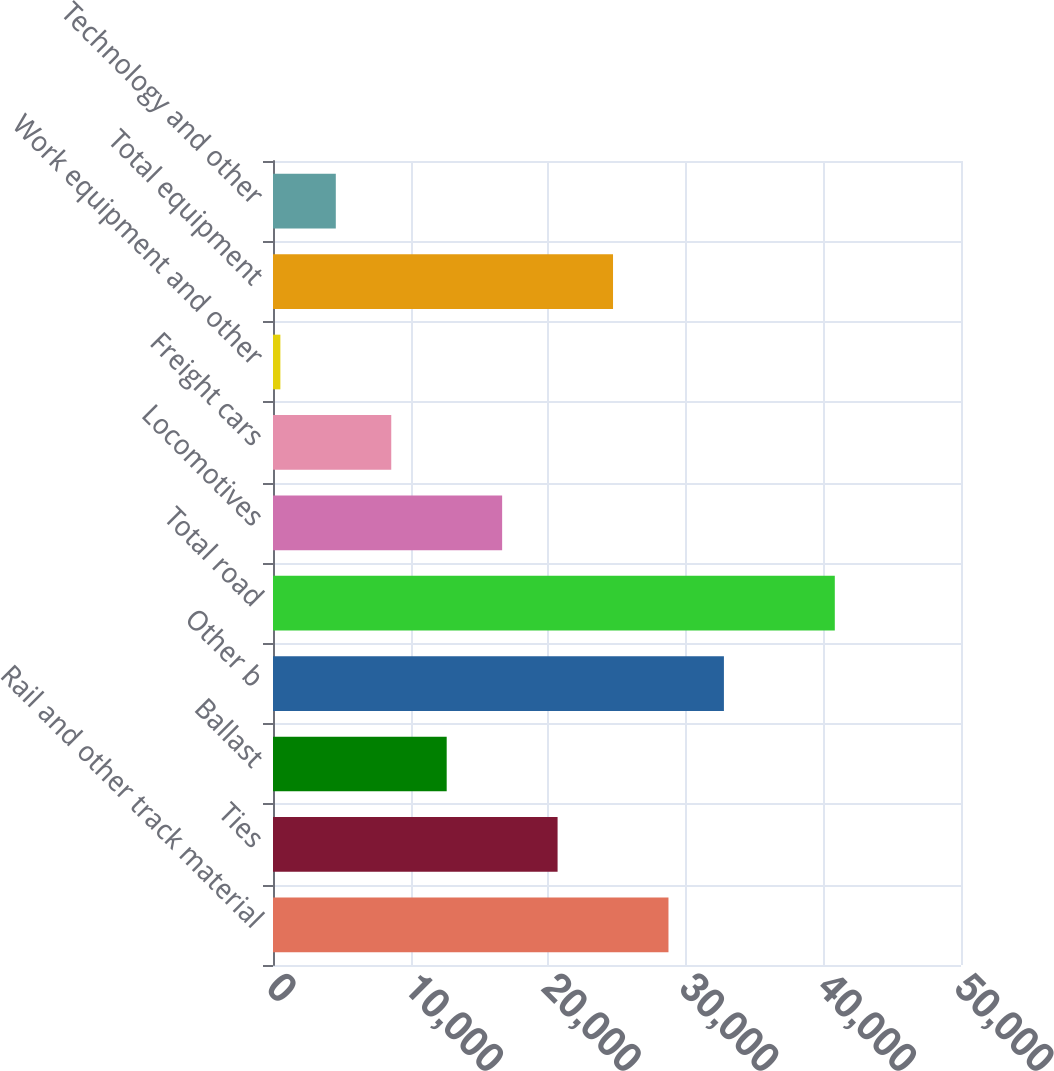<chart> <loc_0><loc_0><loc_500><loc_500><bar_chart><fcel>Rail and other track material<fcel>Ties<fcel>Ballast<fcel>Other b<fcel>Total road<fcel>Locomotives<fcel>Freight cars<fcel>Work equipment and other<fcel>Total equipment<fcel>Technology and other<nl><fcel>28740.8<fcel>20682<fcel>12623.2<fcel>32770.2<fcel>40829<fcel>16652.6<fcel>8593.8<fcel>535<fcel>24711.4<fcel>4564.4<nl></chart> 